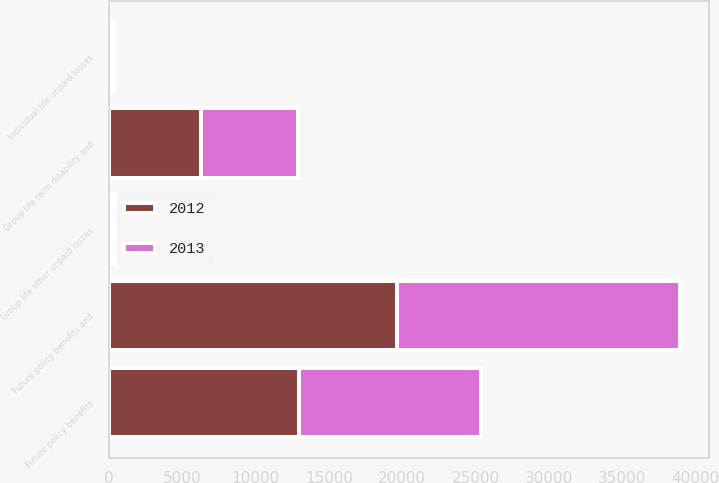<chart> <loc_0><loc_0><loc_500><loc_500><stacked_bar_chart><ecel><fcel>Group life term disability and<fcel>Group life other unpaid losses<fcel>Individual life unpaid losses<fcel>Future policy benefits<fcel>Future policy benefits and<nl><fcel>2012<fcel>6308<fcel>206<fcel>167<fcel>12988<fcel>19669<nl><fcel>2013<fcel>6547<fcel>206<fcel>173<fcel>12350<fcel>19276<nl></chart> 